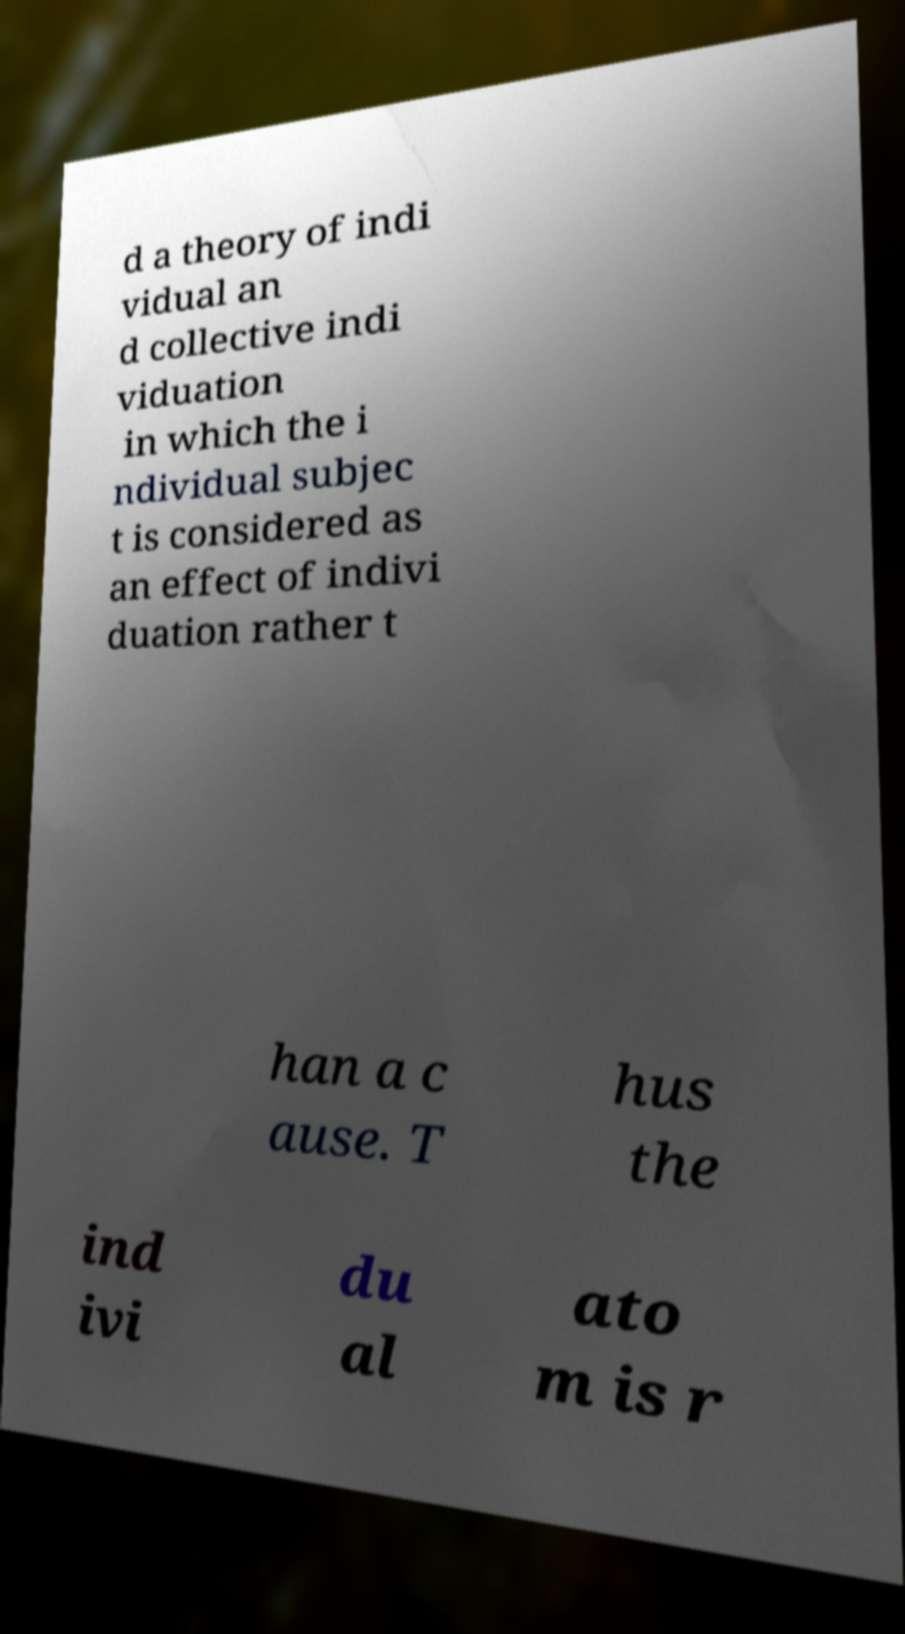There's text embedded in this image that I need extracted. Can you transcribe it verbatim? d a theory of indi vidual an d collective indi viduation in which the i ndividual subjec t is considered as an effect of indivi duation rather t han a c ause. T hus the ind ivi du al ato m is r 